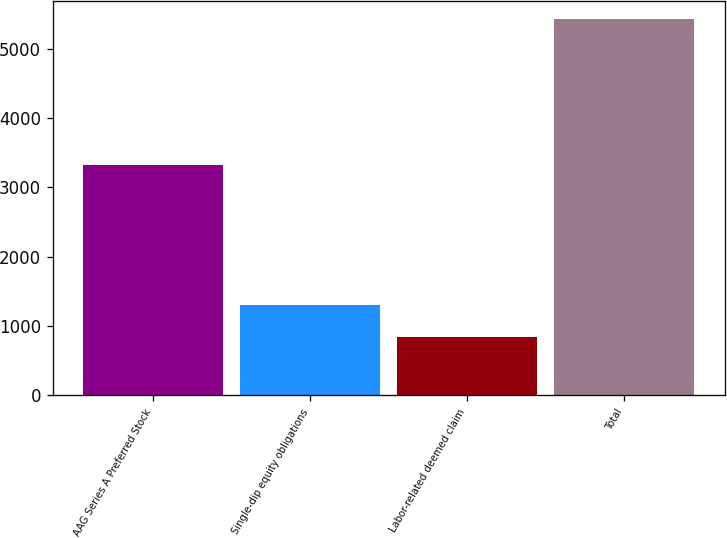Convert chart. <chart><loc_0><loc_0><loc_500><loc_500><bar_chart><fcel>AAG Series A Preferred Stock<fcel>Single-dip equity obligations<fcel>Labor-related deemed claim<fcel>Total<nl><fcel>3329<fcel>1306.5<fcel>849<fcel>5424<nl></chart> 